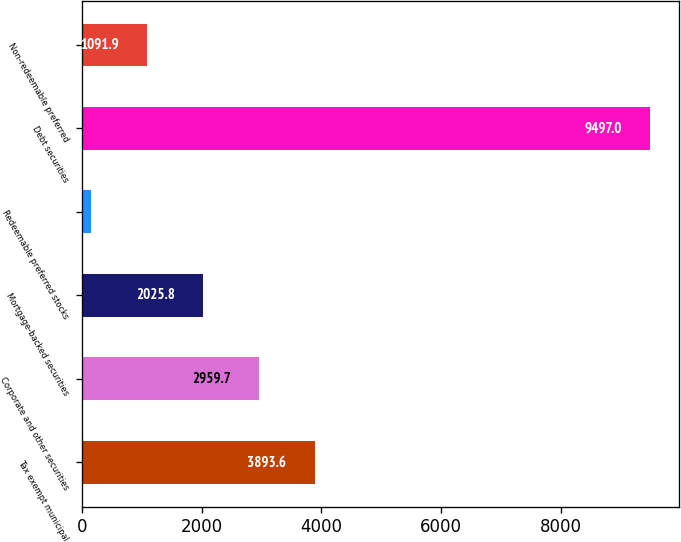Convert chart. <chart><loc_0><loc_0><loc_500><loc_500><bar_chart><fcel>Tax exempt municipal<fcel>Corporate and other securities<fcel>Mortgage-backed securities<fcel>Redeemable preferred stocks<fcel>Debt securities<fcel>Non-redeemable preferred<nl><fcel>3893.6<fcel>2959.7<fcel>2025.8<fcel>158<fcel>9497<fcel>1091.9<nl></chart> 